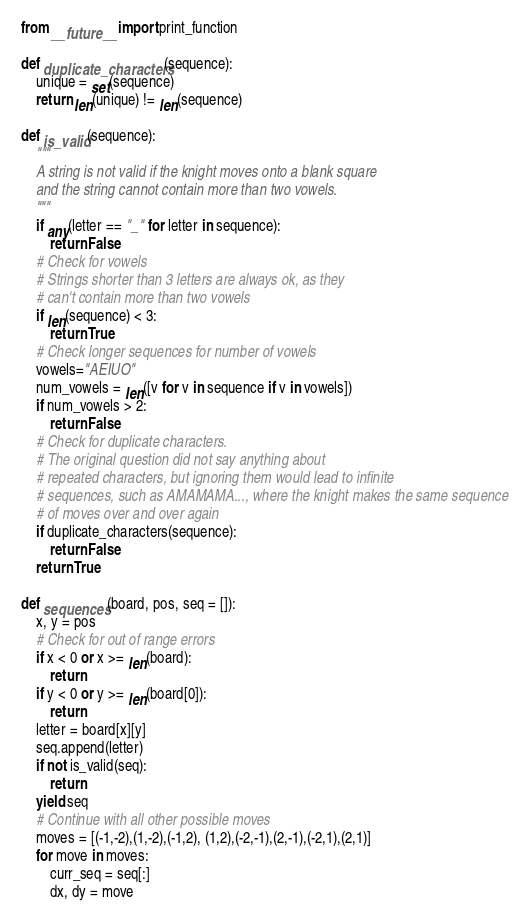<code> <loc_0><loc_0><loc_500><loc_500><_Python_>from __future__ import print_function

def duplicate_characters(sequence):
    unique = set(sequence)
    return len(unique) != len(sequence)

def is_valid(sequence):
    """
    A string is not valid if the knight moves onto a blank square 
    and the string cannot contain more than two vowels.
    """
    if any(letter == "_" for letter in sequence):
        return False
    # Check for vowels
    # Strings shorter than 3 letters are always ok, as they
    # can't contain more than two vowels
    if len(sequence) < 3:
        return True
    # Check longer sequences for number of vowels
    vowels="AEIUO"
    num_vowels = len([v for v in sequence if v in vowels])
    if num_vowels > 2:
        return False
    # Check for duplicate characters.
    # The original question did not say anything about
    # repeated characters, but ignoring them would lead to infinite
    # sequences, such as AMAMAMA..., where the knight makes the same sequence
    # of moves over and over again
    if duplicate_characters(sequence):
        return False
    return True

def sequences(board, pos, seq = []):
    x, y = pos
    # Check for out of range errors
    if x < 0 or x >= len(board):
        return
    if y < 0 or y >= len(board[0]):
        return
    letter = board[x][y]
    seq.append(letter)
    if not is_valid(seq):
        return
    yield seq
    # Continue with all other possible moves
    moves = [(-1,-2),(1,-2),(-1,2), (1,2),(-2,-1),(2,-1),(-2,1),(2,1)]
    for move in moves:
        curr_seq = seq[:]
        dx, dy = move</code> 